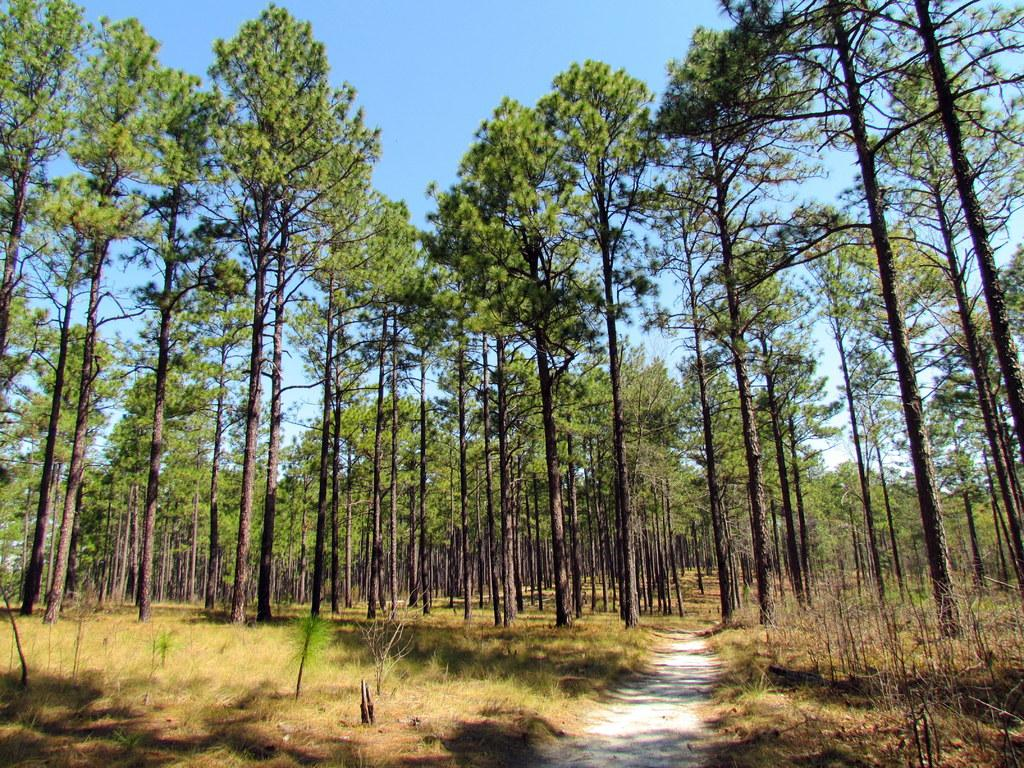What type of vegetation is present in the image? There are many trees in the image. What is the color of the grass on the ground? The grass on the ground is green. What can be seen in the middle of the image? There is a path in the middle of the image. What is visible at the top of the image? The sky is visible at the top of the image. How many minutes does it take for the trees to grow in the image? The image does not show the trees growing, so it is not possible to determine how many minutes it takes for them to grow. What type of pin can be seen holding the grass together in the image? There is no pin present in the image; the grass is not held together by any pin. 